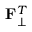Convert formula to latex. <formula><loc_0><loc_0><loc_500><loc_500>F _ { \bot } ^ { T }</formula> 